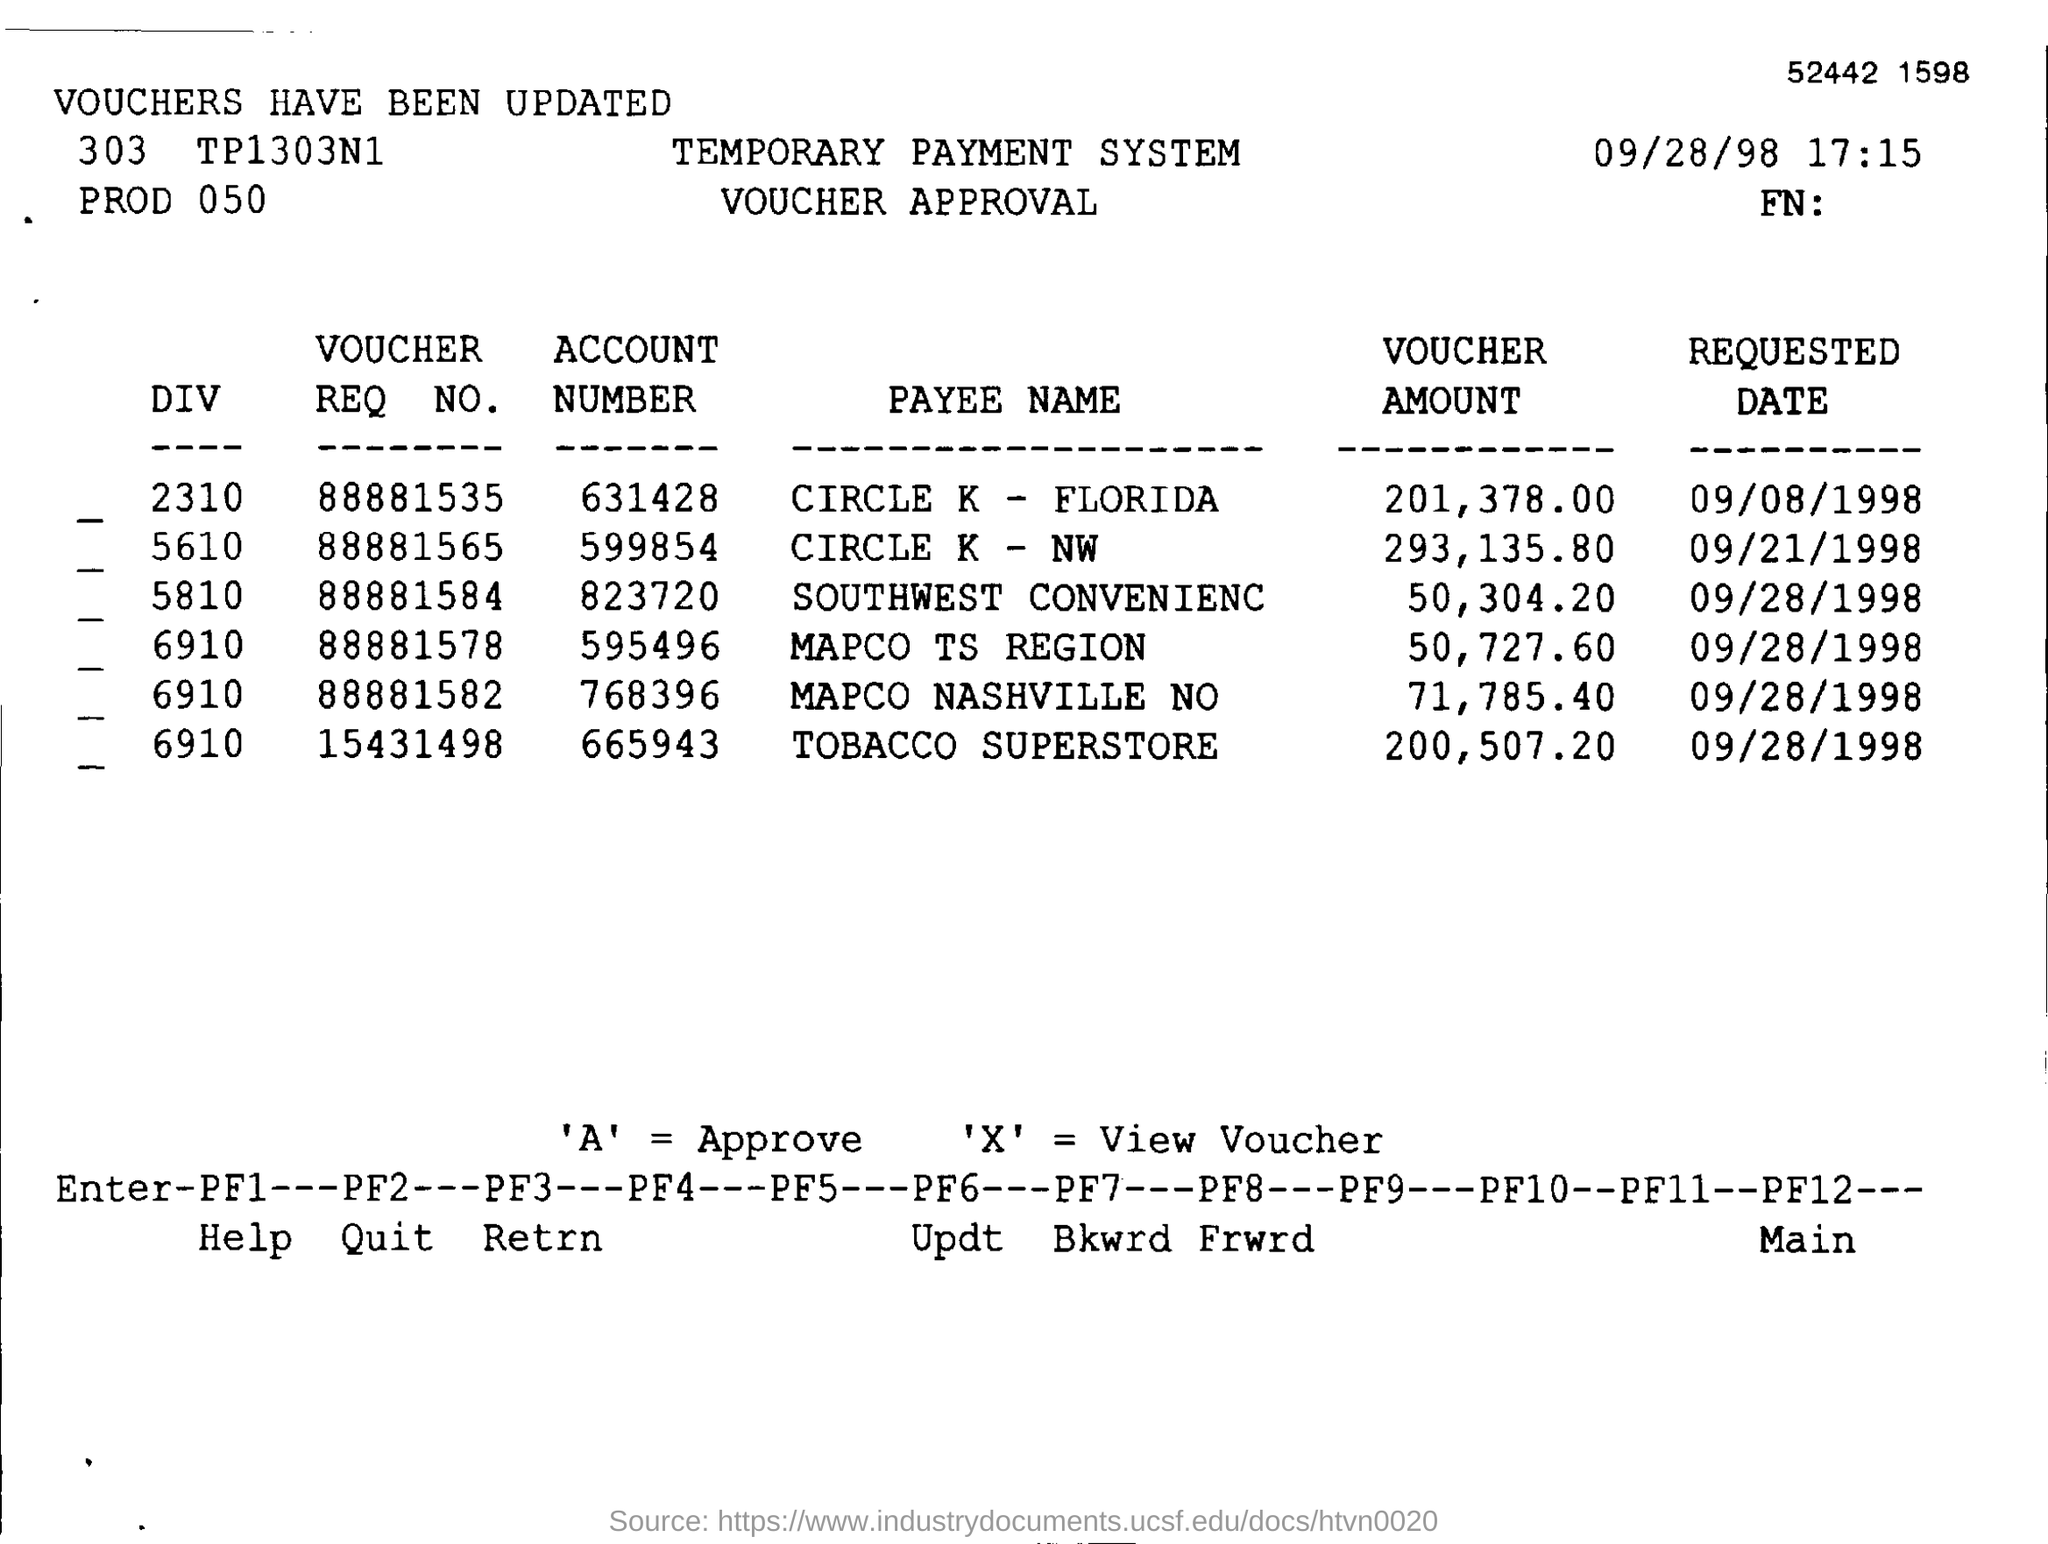What is the Date & Time mentioned in this document?
Your response must be concise. 09/28/98  17:15. What is the Account Number in the payee name of CIRCLE K - NW?
Your response must be concise. 599854. What is the Voucher Req No.  in the Payee Name of TOBACCO SUPERSTORE?
Keep it short and to the point. 15431498. What is the requested date for the account number 631428?
Keep it short and to the point. 09/08/1998. What is the voucher amount in the Payee Name of MAPCO TS REGION?
Give a very brief answer. 50,727.60. What is the voucher amount in the Payee Name of CIRCLE K - FLORIDA?
Keep it short and to the point. 201,378.00. 